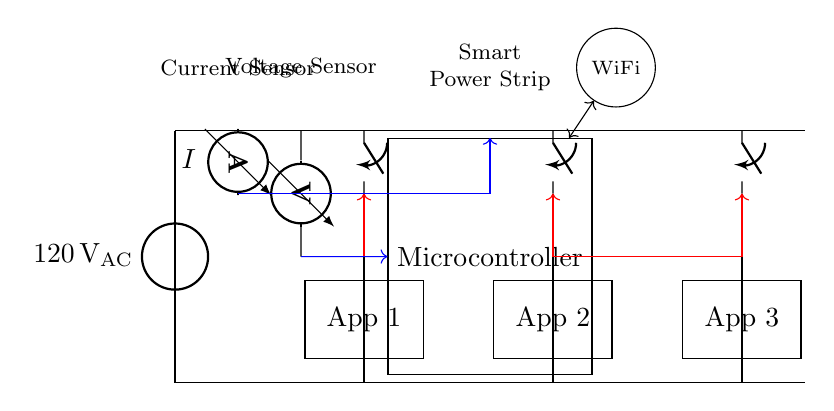What is the voltage of this circuit? The voltage source in the circuit is labeled as 120 volts AC, indicating that this is the voltage provided to the system.
Answer: 120 volts AC What type of sensors are used in this smart power strip? The diagram shows a current sensor and a voltage sensor, which are used to monitor the electrical characteristics of the appliances connected to the power strip.
Answer: Current sensor and voltage sensor How many relays are present in the circuit? There are three relays in the circuit, each associated with one of the appliances shown. This can be determined by counting the switch symbols in the diagram.
Answer: Three What is the purpose of the microcontroller in the circuit? The microcontroller serves as the control unit for the entire system, enabling it to manage the relays and process data from the current and voltage sensors.
Answer: Control unit What do the arrows in red represent? The red arrows indicate control lines from the microcontroller to the relays, showing that the microcontroller can control the switching of the relays for the appliances.
Answer: Control lines What connection type is represented by the purple circles? The WiFi symbol indicates wireless connectivity, which suggests that the microcontroller can communicate with other devices or networks, allowing for remote monitoring and control.
Answer: WiFi connectivity How does the microcontroller receive the current measurement? The current sensor is connected to the microcontroller with a blue arrow, indicating that it sends current measurement data directly to the microcontroller for processing.
Answer: Current measurement data 